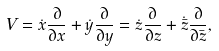Convert formula to latex. <formula><loc_0><loc_0><loc_500><loc_500>{ V } = \dot { x } \frac { \partial } { \partial x } + \dot { y } \frac { \partial } { \partial y } = \dot { z } \frac { \partial } { \partial z } + \dot { \bar { z } } \frac { \partial } { \partial \bar { z } } ,</formula> 